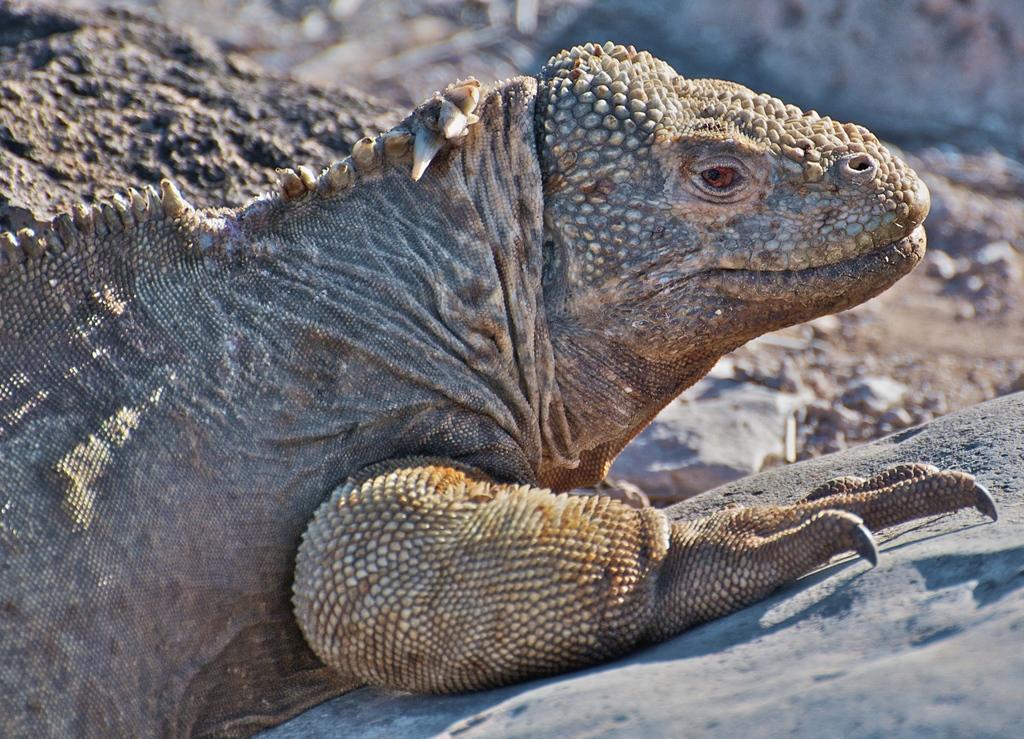How would you summarize this image in a sentence or two? In this picture I can see a reptile and I can see few rocks on the ground. 